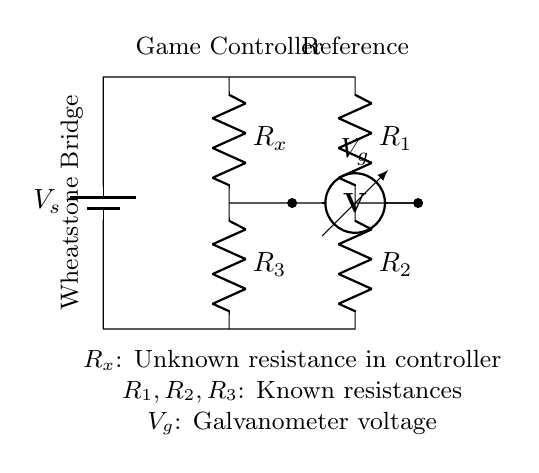What is the role of R_x in this circuit? R_x represents the unknown resistance which is being measured for the game controller input devices. It is placed in the Wheatstone bridge to determine its value by balancing the circuit.
Answer: Unknown resistance What does V_g represent in the diagram? V_g is the voltmeter reading across the two branches of the Wheatstone bridge. It indicates the potential difference between the two nodes that helps establish balance in the bridge circuit for precise measurement of R_x.
Answer: Voltmeter voltage Which resistors are known values? R_1, R_2, and R_3 are the known resistances used in constructing the Wheatstone bridge. They are used to balance the circuit and determine R_x accurately by comparing it with these values.
Answer: R_1, R_2, R_3 How does the Wheatstone bridge achieve balance? The bridge achieves balance when the voltage V_g equals zero, meaning the ratios of the resistances R_1/R_2 and R_x/R_3 become equal. This condition is used to solve for the unknown resistance R_x.
Answer: By equal ratios What is the purpose of having a multiple resistors in this configuration? The multiple resistors (R_1, R_2, R_3) allow for precise adjustment and calibration of the circuit to measure R_x accurately. They create a ratio that is critical in balancing the bridge to get an accurate measurement.
Answer: Precise resistance measurement 